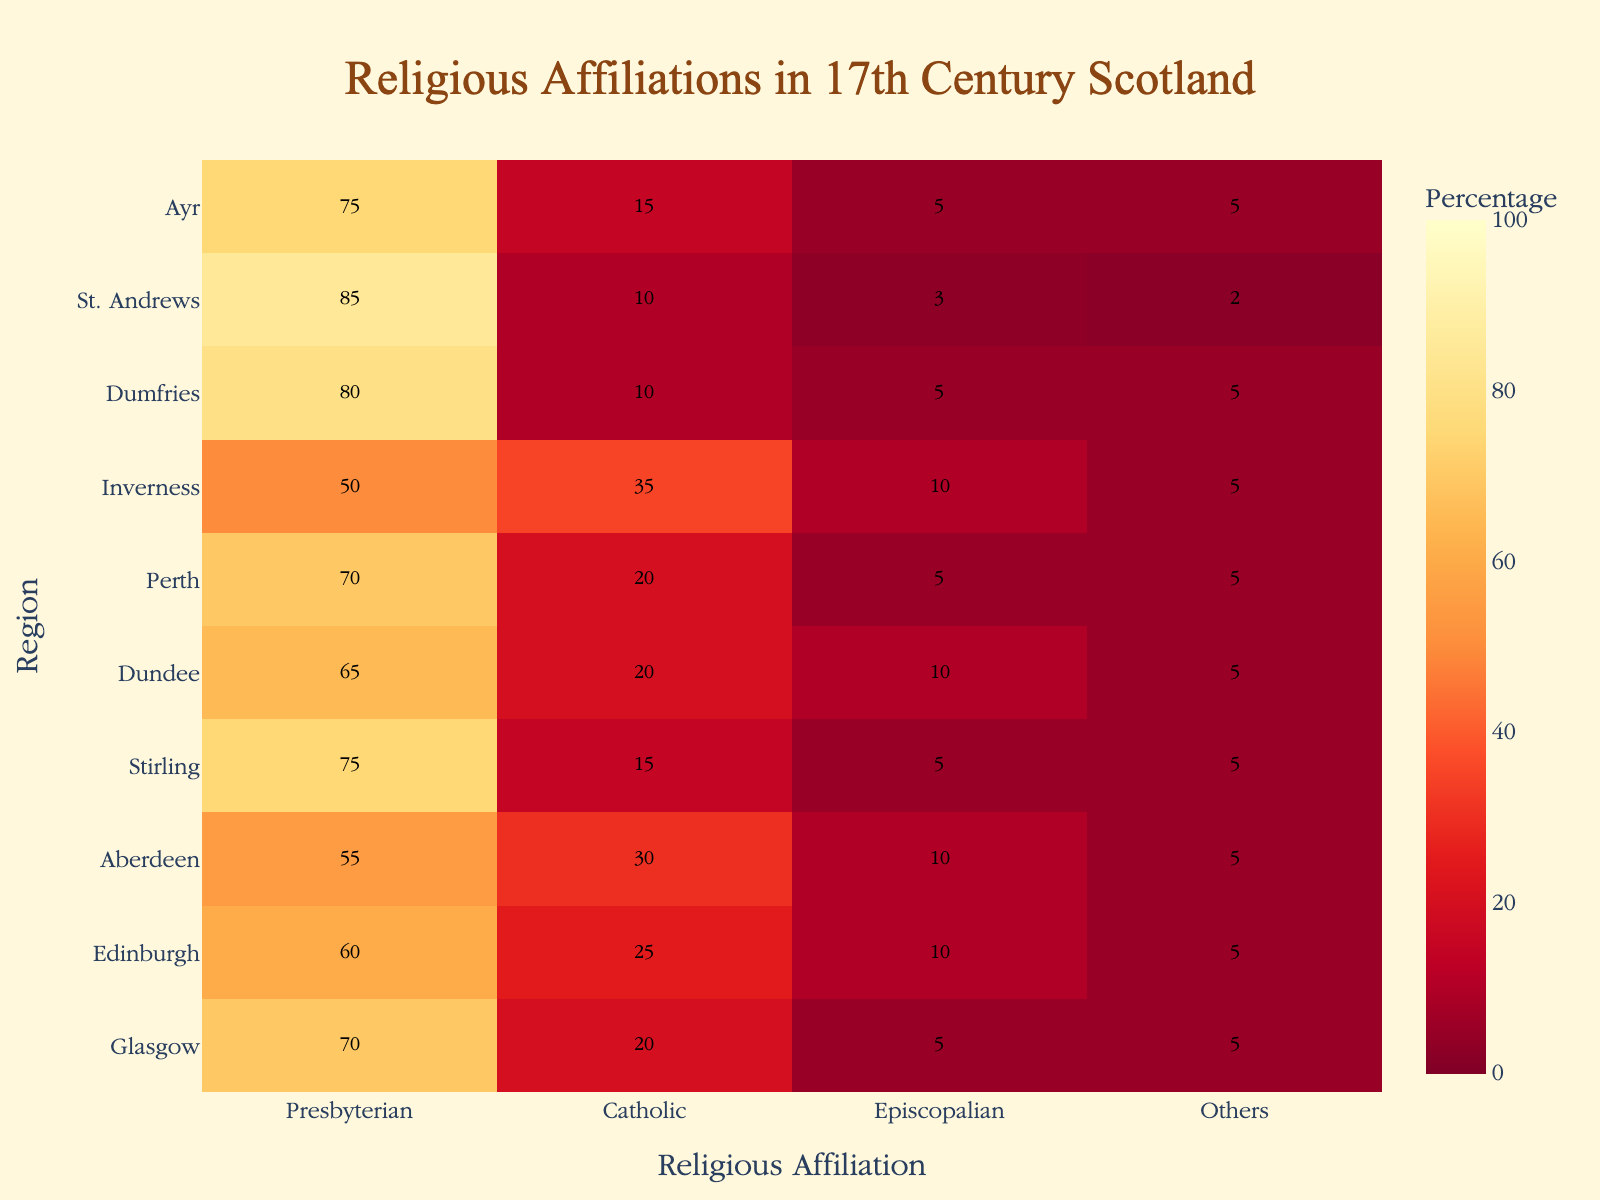What's the title of the heatmap? The title of the heatmap is displayed prominently at the top and reads as "Religious Affiliations in 17th Century Scotland".
Answer: Religious Affiliations in 17th Century Scotland Which region has the highest percentage of Presbyterians? To find the region with the highest percentage of Presbyterians, look along the ‘Presbyterian’ column for the maximum value, which is 85%. This value corresponds to St. Andrews.
Answer: St. Andrews What is the sum of the percentage of Catholics and Episcopalians in Inverness? For Inverness, look at the values under the 'Catholic' and 'Episcopalian' columns, which are 35% and 10%, respectively. Summing them, 35% + 10% = 45%.
Answer: 45% Which region has equal percentages of Presbyterians and others? By checking each region, we find that Glasgow has 70% Presbyterians and 5% 'Others'. No region has equal percentages of these two affiliations.
Answer: None Which city has the highest overall percentage of religious affiliations other than Presbyterian? To find this, sum the percentages of Catholic, Episcopalian, and Others for each region. Inverness has the highest combined total, with Catholic (35%), Episcopalian (10%), and Others (5%) adding up to 50%.
Answer: Inverness What is the average percentage of Presbyterians across all regions? Sum the Presbyterian percentages across all regions and divide by the number of regions: (70 + 60 + 55 + 75 + 65 + 70 + 50 + 80 + 85 + 75) / 10 = 68.5%.
Answer: 68.5% Compare the percentage of Catholics in Glasgow and Dumfries. Which one has more? From the heatmap, Glasgow has 20% Catholics, while Dumfries has only 10%. Therefore, Glasgow has a higher percentage of Catholics.
Answer: Glasgow What is the difference in the percentage of Episcopalians between Edinburgh and Dundee? Edinburgh has 10% Episcopalian, and Dundee also has 10% Episcopalian. The difference is 10% - 10% = 0%.
Answer: 0% How many regions have more than 70% Presbyterians? By checking the 'Presbyterian' percentages, we count St. Andrews (85%), Dumfries (80%), Stirling (75%), Ayr (75%), and Perth (70%). However, only the first four have strictly more than 70%.
Answer: 4 Which two cities have the same percentage distribution for all religious affiliations? By analyzing the heatmap, Glasgow and Perth both have the same percentage distribution: 70% Presbyterian, 20% Catholic, 5% Episcopalian, and 5% Others.
Answer: Glasgow and Perth 